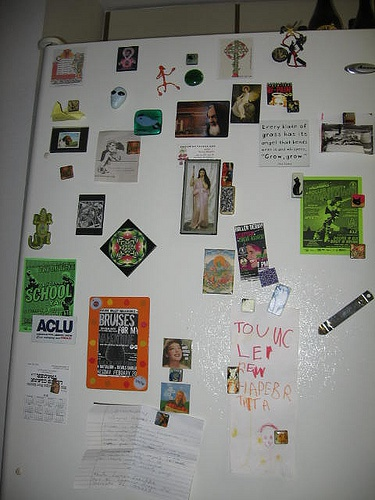Describe the objects in this image and their specific colors. I can see a refrigerator in darkgray, black, and gray tones in this image. 